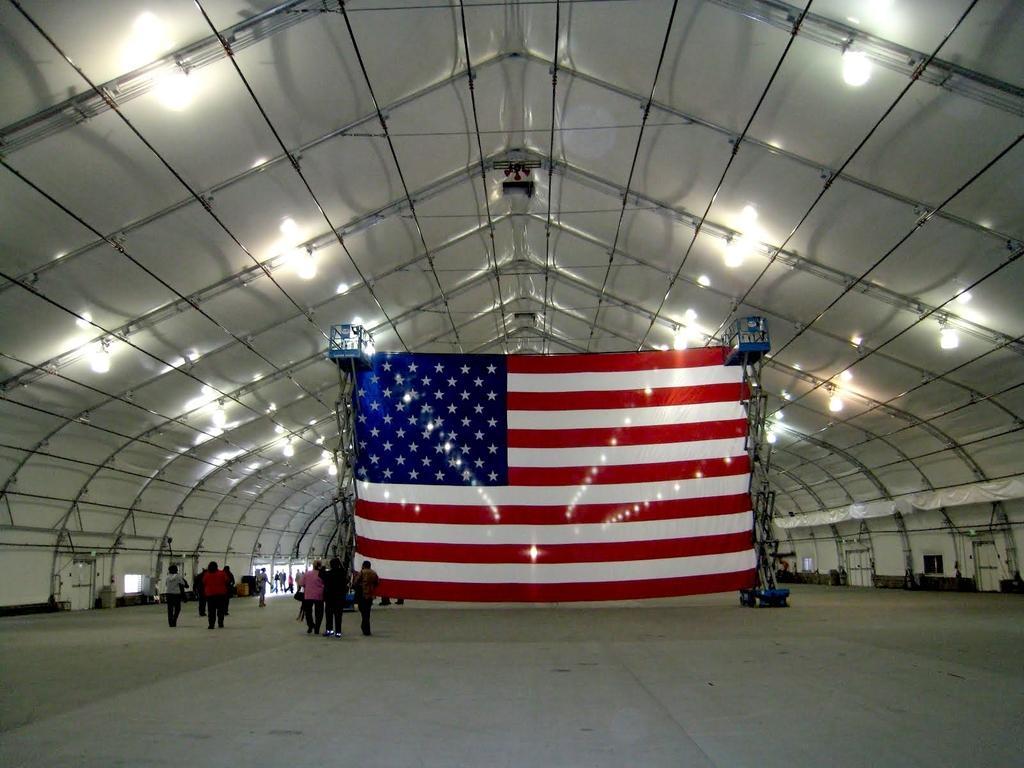Please provide a concise description of this image. In this image we can see a few people on the floor, in the center of the picture there is a flag, at the top of the roof, we can see some rods, poles and lights, there are some doors, windows and other objects. 